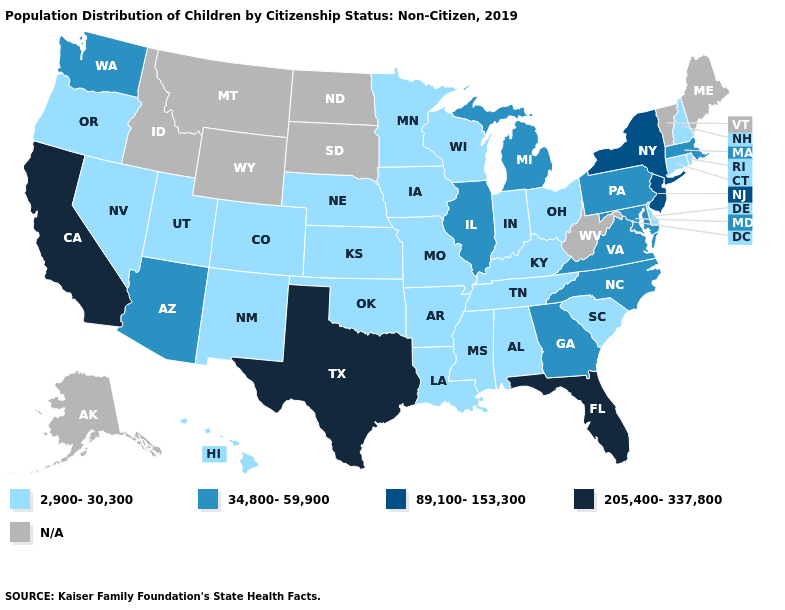Which states hav the highest value in the Northeast?
Quick response, please. New Jersey, New York. Name the states that have a value in the range 205,400-337,800?
Concise answer only. California, Florida, Texas. Does the map have missing data?
Quick response, please. Yes. What is the value of Minnesota?
Give a very brief answer. 2,900-30,300. How many symbols are there in the legend?
Write a very short answer. 5. What is the value of Hawaii?
Concise answer only. 2,900-30,300. Does the map have missing data?
Give a very brief answer. Yes. Which states hav the highest value in the West?
Quick response, please. California. What is the highest value in the West ?
Concise answer only. 205,400-337,800. Name the states that have a value in the range 34,800-59,900?
Quick response, please. Arizona, Georgia, Illinois, Maryland, Massachusetts, Michigan, North Carolina, Pennsylvania, Virginia, Washington. Among the states that border Ohio , does Kentucky have the highest value?
Write a very short answer. No. Does California have the highest value in the USA?
Quick response, please. Yes. Is the legend a continuous bar?
Be succinct. No. Among the states that border Arizona , which have the highest value?
Keep it brief. California. 